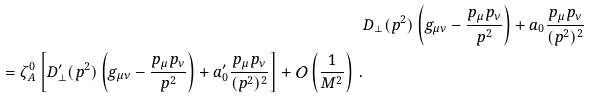Convert formula to latex. <formula><loc_0><loc_0><loc_500><loc_500>& D _ { \bot } ( p ^ { 2 } ) \left ( g _ { \mu \nu } - \frac { p _ { \mu } p _ { \nu } } { p ^ { 2 } } \right ) + a _ { 0 } \frac { p _ { \mu } p _ { \nu } } { ( p ^ { 2 } ) ^ { 2 } } \\ = \zeta _ { A } ^ { 0 } \left [ D ^ { \prime } _ { \bot } ( p ^ { 2 } ) \left ( g _ { \mu \nu } - \frac { p _ { \mu } p _ { \nu } } { p ^ { 2 } } \right ) + a ^ { \prime } _ { 0 } \frac { p _ { \mu } p _ { \nu } } { ( p ^ { 2 } ) ^ { 2 } } \right ] + \mathcal { O } \left ( \frac { 1 } { M ^ { 2 } } \right ) \, .</formula> 